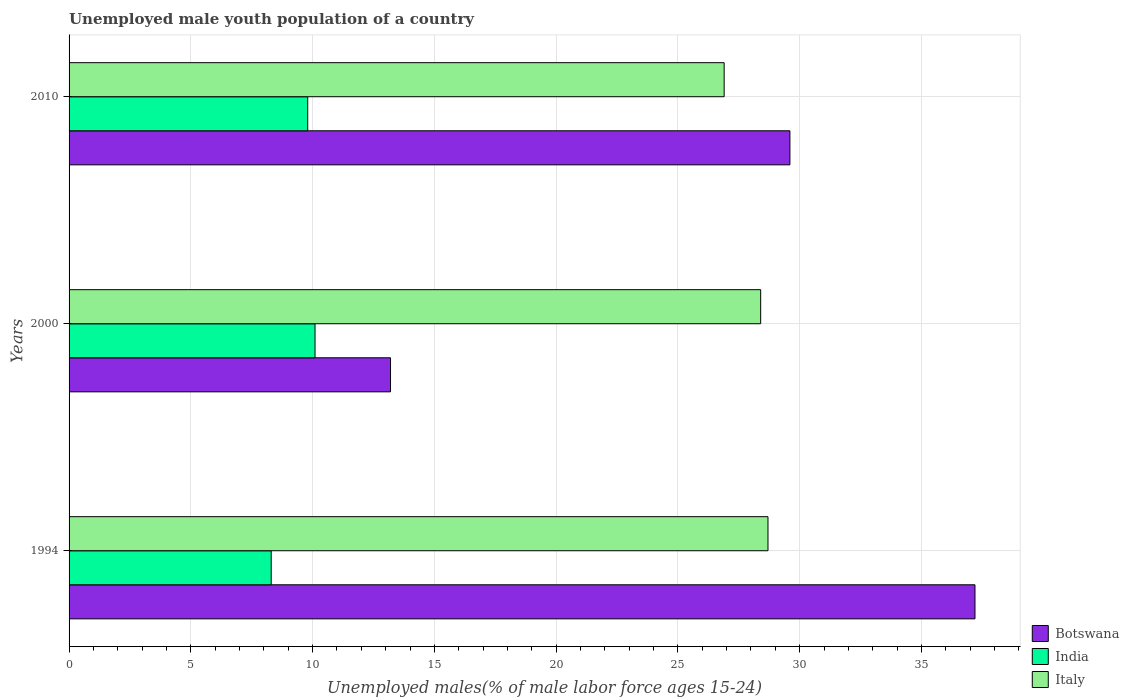How many groups of bars are there?
Your answer should be very brief. 3. How many bars are there on the 2nd tick from the bottom?
Offer a very short reply. 3. What is the percentage of unemployed male youth population in Botswana in 2000?
Your response must be concise. 13.2. Across all years, what is the maximum percentage of unemployed male youth population in Botswana?
Your response must be concise. 37.2. Across all years, what is the minimum percentage of unemployed male youth population in India?
Ensure brevity in your answer.  8.3. In which year was the percentage of unemployed male youth population in India maximum?
Keep it short and to the point. 2000. In which year was the percentage of unemployed male youth population in Italy minimum?
Ensure brevity in your answer.  2010. What is the total percentage of unemployed male youth population in Botswana in the graph?
Keep it short and to the point. 80. What is the difference between the percentage of unemployed male youth population in India in 1994 and that in 2000?
Provide a short and direct response. -1.8. What is the difference between the percentage of unemployed male youth population in Botswana in 1994 and the percentage of unemployed male youth population in India in 2000?
Make the answer very short. 27.1. What is the average percentage of unemployed male youth population in Botswana per year?
Provide a succinct answer. 26.67. In the year 2010, what is the difference between the percentage of unemployed male youth population in Italy and percentage of unemployed male youth population in Botswana?
Your response must be concise. -2.7. In how many years, is the percentage of unemployed male youth population in India greater than 27 %?
Ensure brevity in your answer.  0. What is the ratio of the percentage of unemployed male youth population in Botswana in 1994 to that in 2010?
Offer a terse response. 1.26. Is the percentage of unemployed male youth population in Botswana in 2000 less than that in 2010?
Offer a terse response. Yes. Is the difference between the percentage of unemployed male youth population in Italy in 1994 and 2000 greater than the difference between the percentage of unemployed male youth population in Botswana in 1994 and 2000?
Make the answer very short. No. What is the difference between the highest and the second highest percentage of unemployed male youth population in India?
Ensure brevity in your answer.  0.3. What is the difference between the highest and the lowest percentage of unemployed male youth population in Botswana?
Offer a terse response. 24. In how many years, is the percentage of unemployed male youth population in India greater than the average percentage of unemployed male youth population in India taken over all years?
Give a very brief answer. 2. What does the 2nd bar from the top in 1994 represents?
Your answer should be compact. India. How many years are there in the graph?
Keep it short and to the point. 3. Does the graph contain any zero values?
Ensure brevity in your answer.  No. Does the graph contain grids?
Ensure brevity in your answer.  Yes. How are the legend labels stacked?
Your answer should be compact. Vertical. What is the title of the graph?
Your answer should be compact. Unemployed male youth population of a country. Does "Vietnam" appear as one of the legend labels in the graph?
Offer a terse response. No. What is the label or title of the X-axis?
Your response must be concise. Unemployed males(% of male labor force ages 15-24). What is the Unemployed males(% of male labor force ages 15-24) of Botswana in 1994?
Keep it short and to the point. 37.2. What is the Unemployed males(% of male labor force ages 15-24) of India in 1994?
Make the answer very short. 8.3. What is the Unemployed males(% of male labor force ages 15-24) in Italy in 1994?
Ensure brevity in your answer.  28.7. What is the Unemployed males(% of male labor force ages 15-24) in Botswana in 2000?
Make the answer very short. 13.2. What is the Unemployed males(% of male labor force ages 15-24) in India in 2000?
Make the answer very short. 10.1. What is the Unemployed males(% of male labor force ages 15-24) of Italy in 2000?
Your response must be concise. 28.4. What is the Unemployed males(% of male labor force ages 15-24) of Botswana in 2010?
Your answer should be compact. 29.6. What is the Unemployed males(% of male labor force ages 15-24) in India in 2010?
Offer a very short reply. 9.8. What is the Unemployed males(% of male labor force ages 15-24) in Italy in 2010?
Provide a short and direct response. 26.9. Across all years, what is the maximum Unemployed males(% of male labor force ages 15-24) of Botswana?
Ensure brevity in your answer.  37.2. Across all years, what is the maximum Unemployed males(% of male labor force ages 15-24) in India?
Make the answer very short. 10.1. Across all years, what is the maximum Unemployed males(% of male labor force ages 15-24) of Italy?
Provide a short and direct response. 28.7. Across all years, what is the minimum Unemployed males(% of male labor force ages 15-24) of Botswana?
Make the answer very short. 13.2. Across all years, what is the minimum Unemployed males(% of male labor force ages 15-24) in India?
Keep it short and to the point. 8.3. Across all years, what is the minimum Unemployed males(% of male labor force ages 15-24) of Italy?
Ensure brevity in your answer.  26.9. What is the total Unemployed males(% of male labor force ages 15-24) of Botswana in the graph?
Keep it short and to the point. 80. What is the total Unemployed males(% of male labor force ages 15-24) of India in the graph?
Your response must be concise. 28.2. What is the difference between the Unemployed males(% of male labor force ages 15-24) in India in 1994 and that in 2010?
Your answer should be very brief. -1.5. What is the difference between the Unemployed males(% of male labor force ages 15-24) of Botswana in 2000 and that in 2010?
Your answer should be compact. -16.4. What is the difference between the Unemployed males(% of male labor force ages 15-24) of India in 2000 and that in 2010?
Your answer should be very brief. 0.3. What is the difference between the Unemployed males(% of male labor force ages 15-24) in Botswana in 1994 and the Unemployed males(% of male labor force ages 15-24) in India in 2000?
Offer a very short reply. 27.1. What is the difference between the Unemployed males(% of male labor force ages 15-24) in Botswana in 1994 and the Unemployed males(% of male labor force ages 15-24) in Italy in 2000?
Offer a very short reply. 8.8. What is the difference between the Unemployed males(% of male labor force ages 15-24) in India in 1994 and the Unemployed males(% of male labor force ages 15-24) in Italy in 2000?
Your answer should be very brief. -20.1. What is the difference between the Unemployed males(% of male labor force ages 15-24) in Botswana in 1994 and the Unemployed males(% of male labor force ages 15-24) in India in 2010?
Your response must be concise. 27.4. What is the difference between the Unemployed males(% of male labor force ages 15-24) of India in 1994 and the Unemployed males(% of male labor force ages 15-24) of Italy in 2010?
Provide a succinct answer. -18.6. What is the difference between the Unemployed males(% of male labor force ages 15-24) of Botswana in 2000 and the Unemployed males(% of male labor force ages 15-24) of India in 2010?
Keep it short and to the point. 3.4. What is the difference between the Unemployed males(% of male labor force ages 15-24) of Botswana in 2000 and the Unemployed males(% of male labor force ages 15-24) of Italy in 2010?
Ensure brevity in your answer.  -13.7. What is the difference between the Unemployed males(% of male labor force ages 15-24) in India in 2000 and the Unemployed males(% of male labor force ages 15-24) in Italy in 2010?
Make the answer very short. -16.8. What is the average Unemployed males(% of male labor force ages 15-24) in Botswana per year?
Provide a succinct answer. 26.67. What is the average Unemployed males(% of male labor force ages 15-24) in Italy per year?
Your answer should be compact. 28. In the year 1994, what is the difference between the Unemployed males(% of male labor force ages 15-24) of Botswana and Unemployed males(% of male labor force ages 15-24) of India?
Provide a short and direct response. 28.9. In the year 1994, what is the difference between the Unemployed males(% of male labor force ages 15-24) in Botswana and Unemployed males(% of male labor force ages 15-24) in Italy?
Ensure brevity in your answer.  8.5. In the year 1994, what is the difference between the Unemployed males(% of male labor force ages 15-24) of India and Unemployed males(% of male labor force ages 15-24) of Italy?
Make the answer very short. -20.4. In the year 2000, what is the difference between the Unemployed males(% of male labor force ages 15-24) in Botswana and Unemployed males(% of male labor force ages 15-24) in India?
Make the answer very short. 3.1. In the year 2000, what is the difference between the Unemployed males(% of male labor force ages 15-24) of Botswana and Unemployed males(% of male labor force ages 15-24) of Italy?
Offer a very short reply. -15.2. In the year 2000, what is the difference between the Unemployed males(% of male labor force ages 15-24) in India and Unemployed males(% of male labor force ages 15-24) in Italy?
Provide a short and direct response. -18.3. In the year 2010, what is the difference between the Unemployed males(% of male labor force ages 15-24) in Botswana and Unemployed males(% of male labor force ages 15-24) in India?
Provide a short and direct response. 19.8. In the year 2010, what is the difference between the Unemployed males(% of male labor force ages 15-24) of India and Unemployed males(% of male labor force ages 15-24) of Italy?
Offer a terse response. -17.1. What is the ratio of the Unemployed males(% of male labor force ages 15-24) of Botswana in 1994 to that in 2000?
Ensure brevity in your answer.  2.82. What is the ratio of the Unemployed males(% of male labor force ages 15-24) of India in 1994 to that in 2000?
Offer a very short reply. 0.82. What is the ratio of the Unemployed males(% of male labor force ages 15-24) in Italy in 1994 to that in 2000?
Make the answer very short. 1.01. What is the ratio of the Unemployed males(% of male labor force ages 15-24) in Botswana in 1994 to that in 2010?
Provide a short and direct response. 1.26. What is the ratio of the Unemployed males(% of male labor force ages 15-24) in India in 1994 to that in 2010?
Your answer should be compact. 0.85. What is the ratio of the Unemployed males(% of male labor force ages 15-24) in Italy in 1994 to that in 2010?
Ensure brevity in your answer.  1.07. What is the ratio of the Unemployed males(% of male labor force ages 15-24) of Botswana in 2000 to that in 2010?
Provide a short and direct response. 0.45. What is the ratio of the Unemployed males(% of male labor force ages 15-24) in India in 2000 to that in 2010?
Your answer should be compact. 1.03. What is the ratio of the Unemployed males(% of male labor force ages 15-24) of Italy in 2000 to that in 2010?
Provide a short and direct response. 1.06. What is the difference between the highest and the second highest Unemployed males(% of male labor force ages 15-24) of Italy?
Your response must be concise. 0.3. What is the difference between the highest and the lowest Unemployed males(% of male labor force ages 15-24) in Botswana?
Provide a short and direct response. 24. What is the difference between the highest and the lowest Unemployed males(% of male labor force ages 15-24) of India?
Make the answer very short. 1.8. 